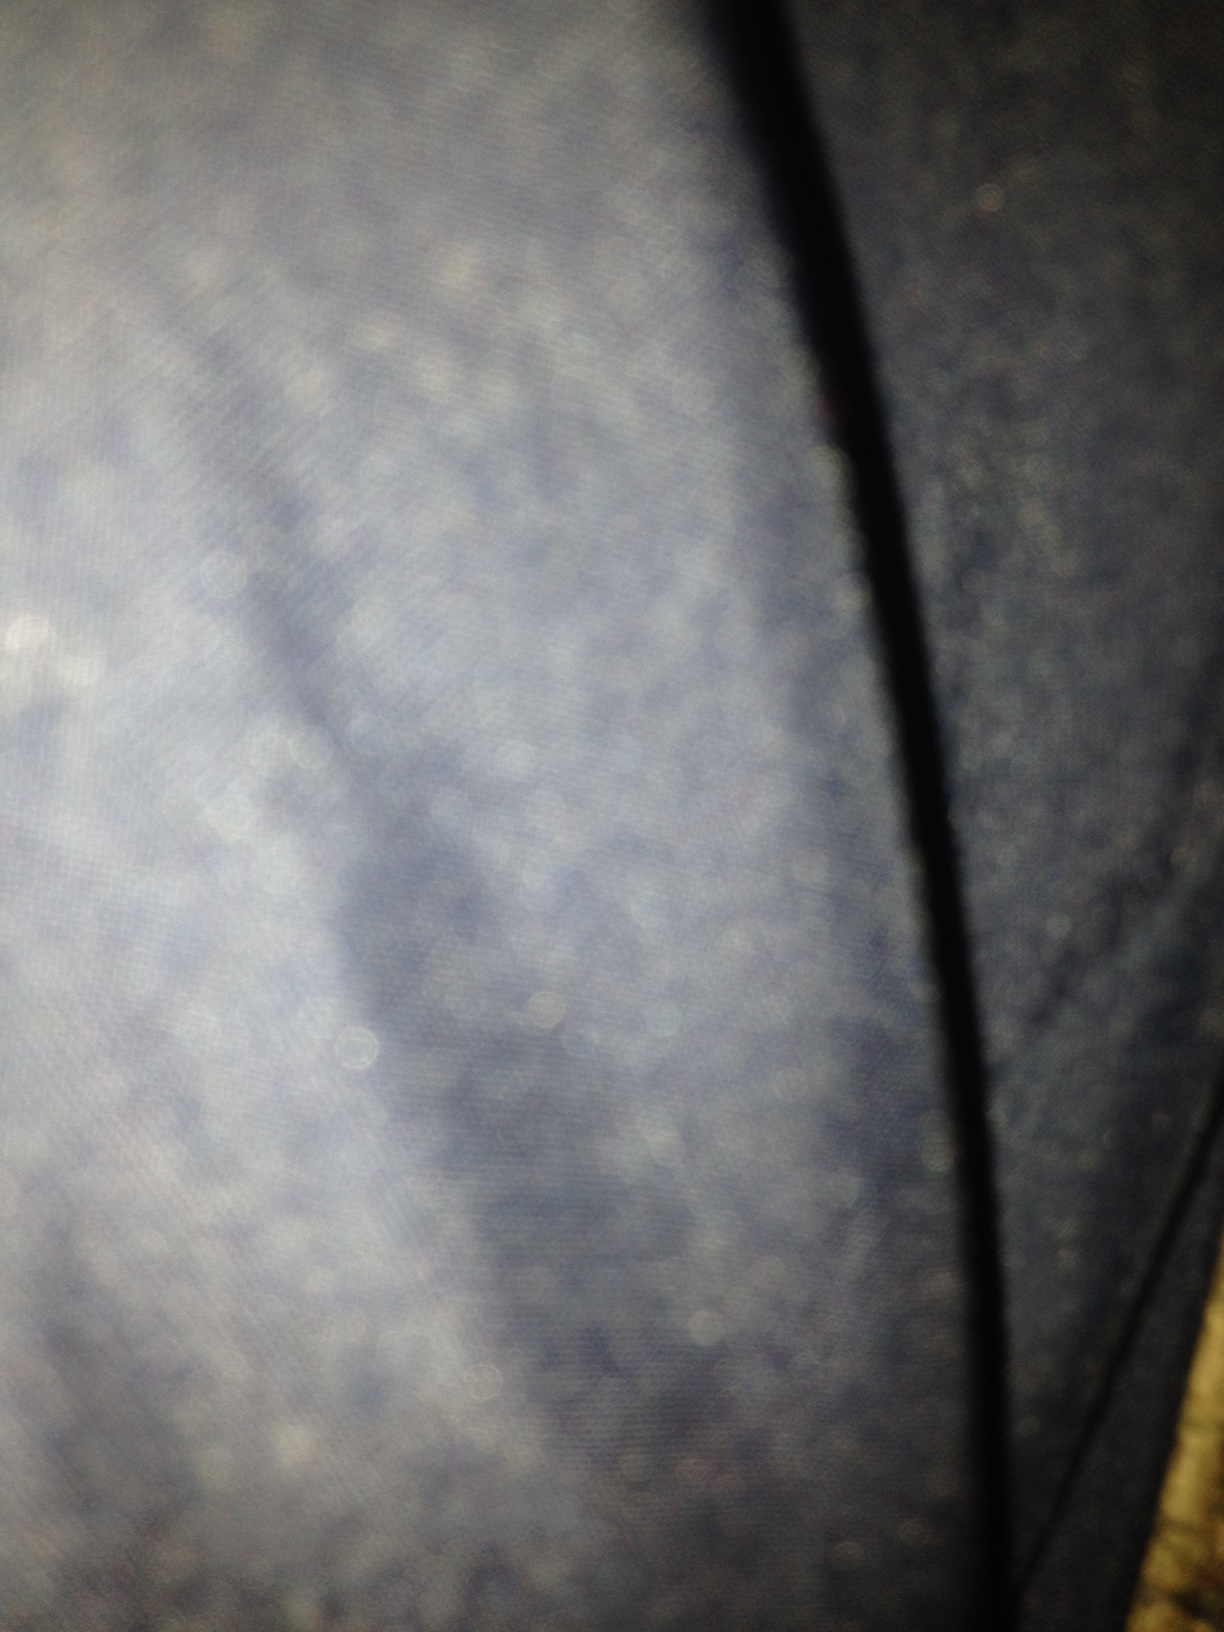What could be reasons for a picture turning out this blurry? A blurry picture like this typically results from a few common issues: the camera was too close to the subject without adequate time to focus, movement during the photo taking, or improper lighting conditions that affected the camera's ability to capture sharp images. 